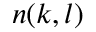<formula> <loc_0><loc_0><loc_500><loc_500>n ( k , l )</formula> 